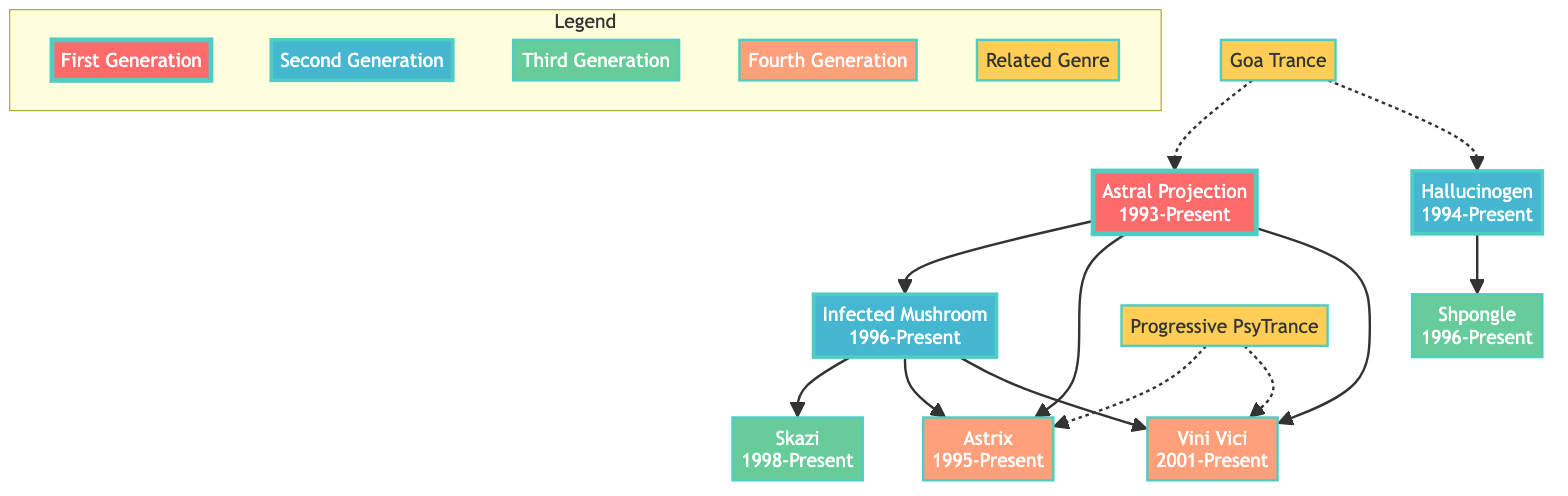What is the origin of Astral Projection? The diagram shows that Astral Projection's origin is listed as "Israel." This can be found in the node representing Astral Projection at the top of the family tree.
Answer: Israel How many artists are in the second generation? By analyzing the diagram, I can see that there are two nodes connected to the first generation node (Astral Projection) that represent artists from the second generation. These nodes are for Infected Mushroom and Hallucinogen.
Answer: 2 Who influences Shpongle? To find the influences of Shpongle, I look at the node for Shpongle in the third generation. The influences listed there include Hallucinogen.
Answer: Hallucinogen Which generation is Skazi part of? By looking at the position of Skazi in the diagram, it is connected to the second generation node (Infected Mushroom), indicating that Skazi is part of the third generation. This can be confirmed by its placement in the layer of third-generation artists.
Answer: Third Generation What notable works are associated with Vini Vici? In the diagram, the notable works for Vini Vici are clearly listed as "Future Classics" and "Namaste." This information can be found in the corresponding node for Vini Vici in the fourth generation.
Answer: Future Classics, Namaste How are Astral Projection and Infected Mushroom related? The relationship can be understood by following the directed edge from Astral Projection to Infected Mushroom, indicating a direct influence from Astral Projection to Infected Mushroom within the lineage structure of the diagram.
Answer: Influences Who is the only artist in the fourth generation that has influences from Infected Mushroom? By examining the fourth generation artists, I find that Astrix and Vini Vici are listed there; however, Skazi (in the third generation) mentions Infected Mushroom as an influence, indicating that Skazi is the only artist related to Infected Mushroom from the generations beneath it.
Answer: Skazi Which genre is associated with prominent artists like Ace Ventura? The related genres section of the diagram lists "Progressive PsyTrance" as the genre associated with artist Ace Ventura. This can be directly found in the related genres section where Progressive PsyTrance is outlined.
Answer: Progressive PsyTrance How many notable works does Hallucinogen have listed? By looking at the node corresponding to Hallucinogen in the second generation, I can see that it lists two notable works: "Twisted" and "The Lone Deranger." Therefore, there are two notable works mentioned for this artist.
Answer: 2 